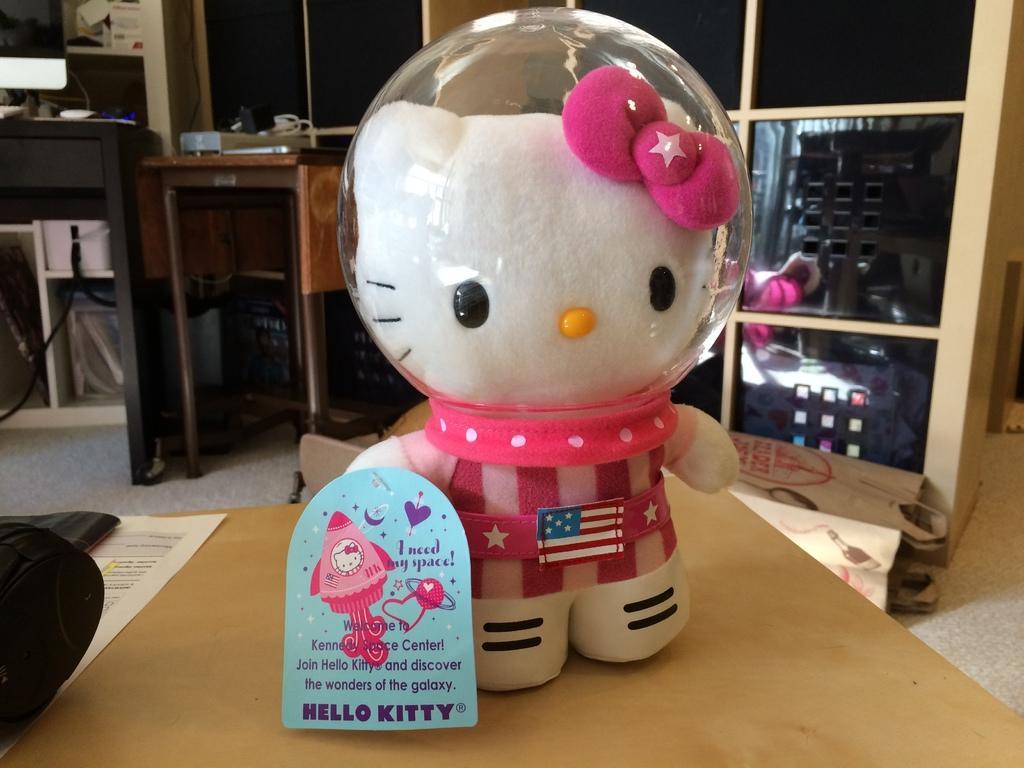In one or two sentences, can you explain what this image depicts? There is a toy on the table,behind it there are tables and rack. 